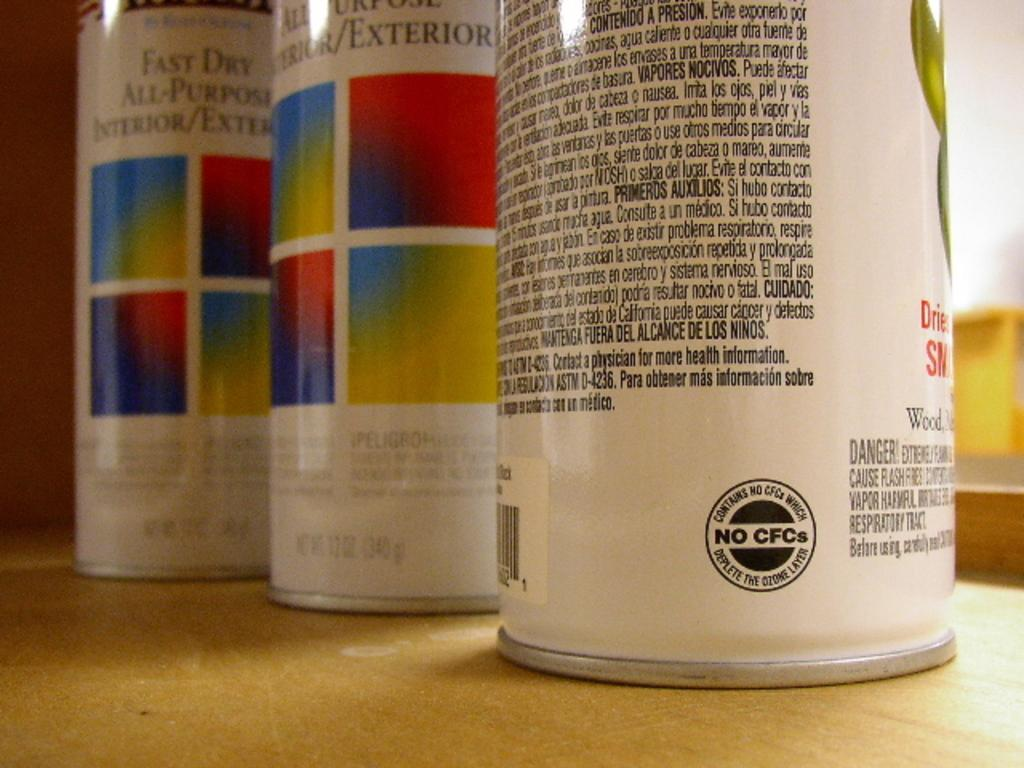<image>
Write a terse but informative summary of the picture. A can of paint has a label on it that says it does not contain CFCs. 